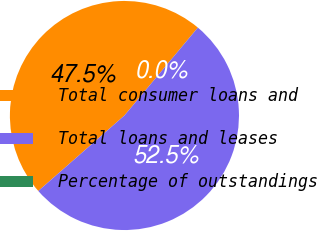Convert chart. <chart><loc_0><loc_0><loc_500><loc_500><pie_chart><fcel>Total consumer loans and<fcel>Total loans and leases<fcel>Percentage of outstandings<nl><fcel>47.53%<fcel>52.47%<fcel>0.01%<nl></chart> 